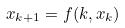<formula> <loc_0><loc_0><loc_500><loc_500>x _ { k + 1 } = f ( k , x _ { k } )</formula> 